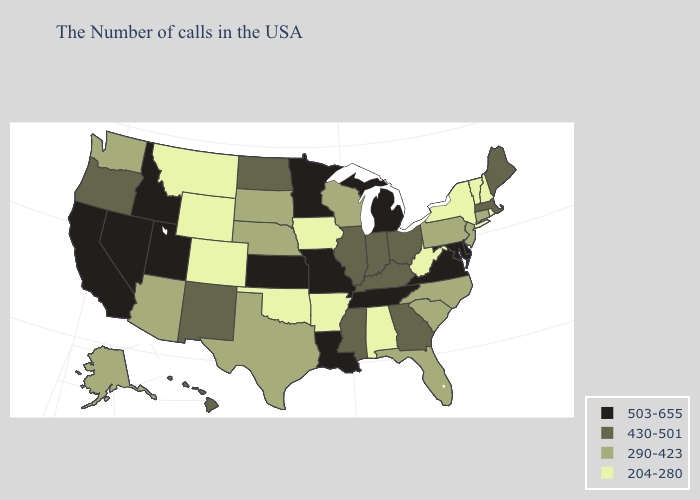Name the states that have a value in the range 204-280?
Concise answer only. Rhode Island, New Hampshire, Vermont, New York, West Virginia, Alabama, Arkansas, Iowa, Oklahoma, Wyoming, Colorado, Montana. Among the states that border Georgia , which have the lowest value?
Concise answer only. Alabama. What is the lowest value in states that border Colorado?
Concise answer only. 204-280. Does Illinois have the lowest value in the USA?
Give a very brief answer. No. Does Arkansas have a lower value than Tennessee?
Write a very short answer. Yes. Is the legend a continuous bar?
Give a very brief answer. No. What is the lowest value in states that border California?
Keep it brief. 290-423. Among the states that border West Virginia , does Pennsylvania have the highest value?
Be succinct. No. Among the states that border Kansas , does Oklahoma have the highest value?
Answer briefly. No. What is the highest value in the Northeast ?
Give a very brief answer. 430-501. What is the value of Delaware?
Give a very brief answer. 503-655. Does North Carolina have a higher value than Minnesota?
Concise answer only. No. What is the value of Washington?
Give a very brief answer. 290-423. What is the value of Minnesota?
Be succinct. 503-655. What is the value of Utah?
Be succinct. 503-655. 